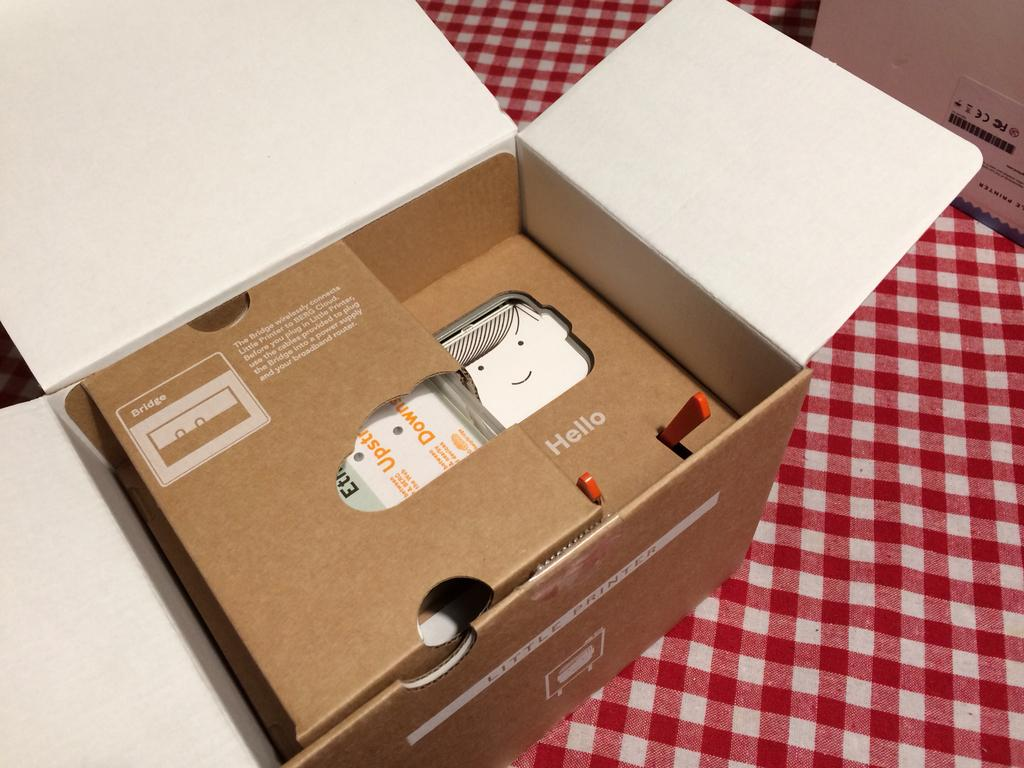<image>
Summarize the visual content of the image. A cardboard box with a message that says hello is opened and on a red and white kitchen table. 